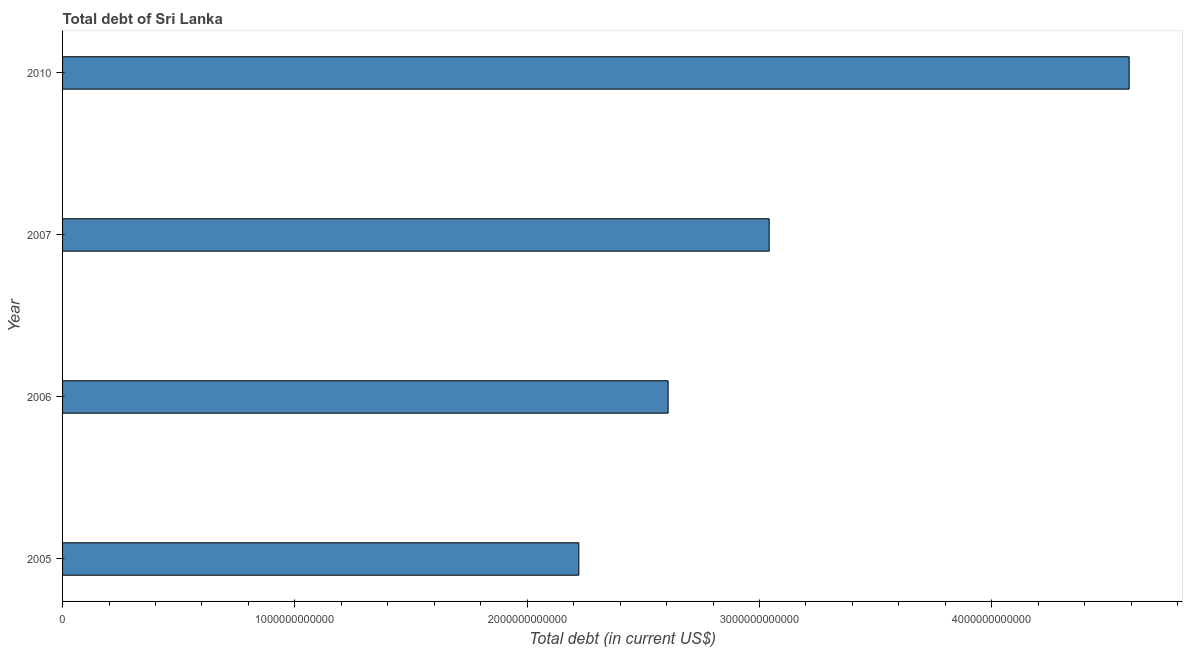What is the title of the graph?
Offer a very short reply. Total debt of Sri Lanka. What is the label or title of the X-axis?
Provide a short and direct response. Total debt (in current US$). What is the total debt in 2010?
Keep it short and to the point. 4.59e+12. Across all years, what is the maximum total debt?
Make the answer very short. 4.59e+12. Across all years, what is the minimum total debt?
Offer a terse response. 2.22e+12. What is the sum of the total debt?
Keep it short and to the point. 1.25e+13. What is the difference between the total debt in 2005 and 2007?
Keep it short and to the point. -8.19e+11. What is the average total debt per year?
Your answer should be very brief. 3.12e+12. What is the median total debt?
Give a very brief answer. 2.82e+12. Do a majority of the years between 2007 and 2005 (inclusive) have total debt greater than 2200000000000 US$?
Keep it short and to the point. Yes. What is the ratio of the total debt in 2005 to that in 2007?
Provide a succinct answer. 0.73. What is the difference between the highest and the second highest total debt?
Your answer should be very brief. 1.55e+12. Is the sum of the total debt in 2005 and 2010 greater than the maximum total debt across all years?
Keep it short and to the point. Yes. What is the difference between the highest and the lowest total debt?
Offer a very short reply. 2.37e+12. In how many years, is the total debt greater than the average total debt taken over all years?
Your answer should be compact. 1. How many bars are there?
Your response must be concise. 4. Are all the bars in the graph horizontal?
Give a very brief answer. Yes. How many years are there in the graph?
Make the answer very short. 4. What is the difference between two consecutive major ticks on the X-axis?
Offer a very short reply. 1.00e+12. Are the values on the major ticks of X-axis written in scientific E-notation?
Ensure brevity in your answer.  No. What is the Total debt (in current US$) of 2005?
Provide a succinct answer. 2.22e+12. What is the Total debt (in current US$) of 2006?
Offer a very short reply. 2.61e+12. What is the Total debt (in current US$) of 2007?
Make the answer very short. 3.04e+12. What is the Total debt (in current US$) of 2010?
Keep it short and to the point. 4.59e+12. What is the difference between the Total debt (in current US$) in 2005 and 2006?
Offer a very short reply. -3.84e+11. What is the difference between the Total debt (in current US$) in 2005 and 2007?
Offer a very short reply. -8.19e+11. What is the difference between the Total debt (in current US$) in 2005 and 2010?
Offer a terse response. -2.37e+12. What is the difference between the Total debt (in current US$) in 2006 and 2007?
Offer a terse response. -4.35e+11. What is the difference between the Total debt (in current US$) in 2006 and 2010?
Offer a very short reply. -1.98e+12. What is the difference between the Total debt (in current US$) in 2007 and 2010?
Your answer should be very brief. -1.55e+12. What is the ratio of the Total debt (in current US$) in 2005 to that in 2006?
Make the answer very short. 0.85. What is the ratio of the Total debt (in current US$) in 2005 to that in 2007?
Give a very brief answer. 0.73. What is the ratio of the Total debt (in current US$) in 2005 to that in 2010?
Offer a very short reply. 0.48. What is the ratio of the Total debt (in current US$) in 2006 to that in 2007?
Your response must be concise. 0.86. What is the ratio of the Total debt (in current US$) in 2006 to that in 2010?
Offer a terse response. 0.57. What is the ratio of the Total debt (in current US$) in 2007 to that in 2010?
Provide a short and direct response. 0.66. 